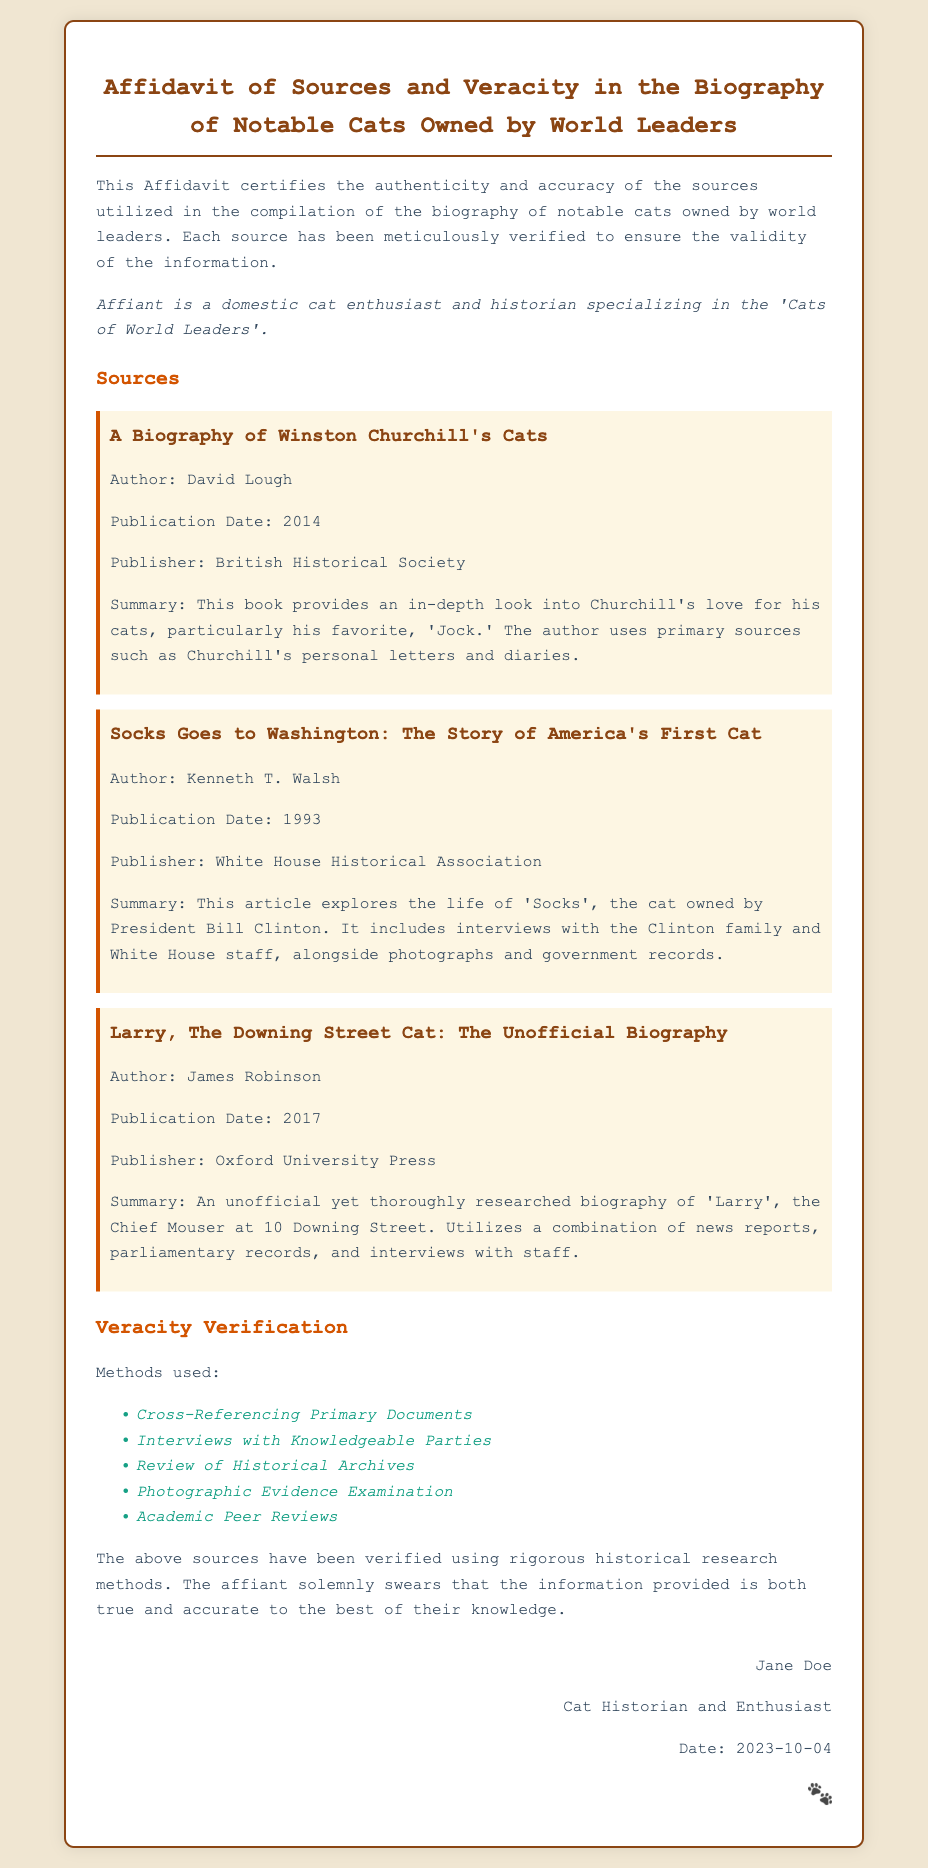What is the title of the Affidavit? The title is stated at the beginning of the document, which indicates the purpose and focus of the affidavit.
Answer: Affidavit of Sources and Veracity in the Biography of Notable Cats Owned by World Leaders Who is the author of "A Biography of Winston Churchill's Cats"? The document lists the author for this specific source, which is crucial for attributing the work.
Answer: David Lough What year was "Socks Goes to Washington: The Story of America's First Cat" published? The publication date is important for understanding the context and timeframe of the information provided in the document.
Answer: 1993 How many methods were used for veracity verification? The document lists different methods used for verification, which gives insight into the thoroughness of the research.
Answer: Five What is the name of the Chief Mouser at 10 Downing Street? This question seeks a specific title or name that appears in the mentioned sources relating to the notable cats of world leaders.
Answer: Larry What type of affiliation does the affiant have? The document details the background of the affiant, which is relevant to their credibility and perspective on the topic.
Answer: Cat Historian and Enthusiast What publisher released the book about Larry the Downing Street Cat? Identifying the publisher is relevant to understanding the credibility of the source.
Answer: Oxford University Press What photographic evidence examination involves? This question asks about one of the specific methods used in validating the sources, showing the comprehensive approach taken in the affidavit.
Answer: Review of Historical Archives What date was the affidavit signed? The signing date of the affidavit is critical for understanding its currency and relevance at the time of signing.
Answer: 2023-10-04 